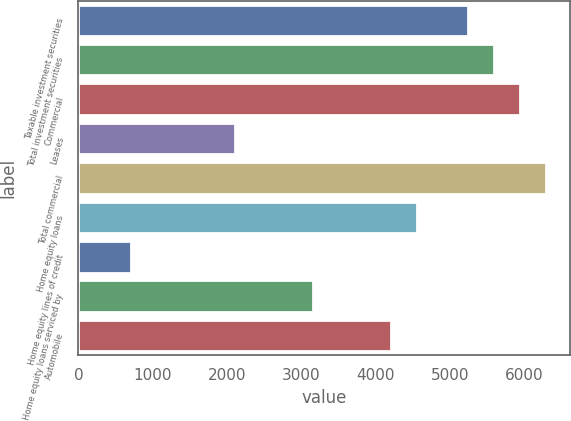Convert chart. <chart><loc_0><loc_0><loc_500><loc_500><bar_chart><fcel>Taxable investment securities<fcel>Total investment securities<fcel>Commercial<fcel>Leases<fcel>Total commercial<fcel>Home equity loans<fcel>Home equity lines of credit<fcel>Home equity loans serviced by<fcel>Automobile<nl><fcel>5249.5<fcel>5599.2<fcel>5948.9<fcel>2102.2<fcel>6298.6<fcel>4550.1<fcel>703.4<fcel>3151.3<fcel>4200.4<nl></chart> 